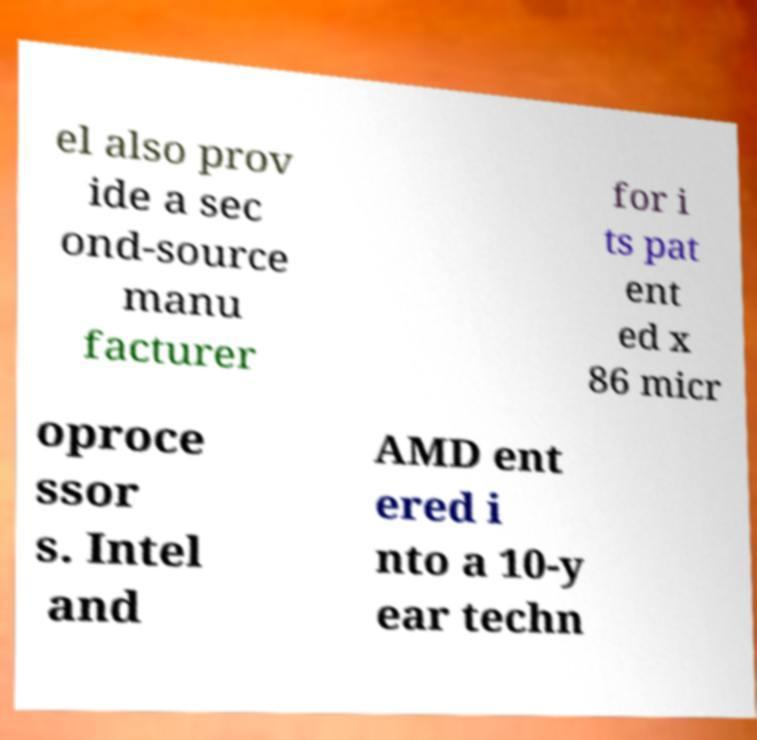For documentation purposes, I need the text within this image transcribed. Could you provide that? el also prov ide a sec ond-source manu facturer for i ts pat ent ed x 86 micr oproce ssor s. Intel and AMD ent ered i nto a 10-y ear techn 